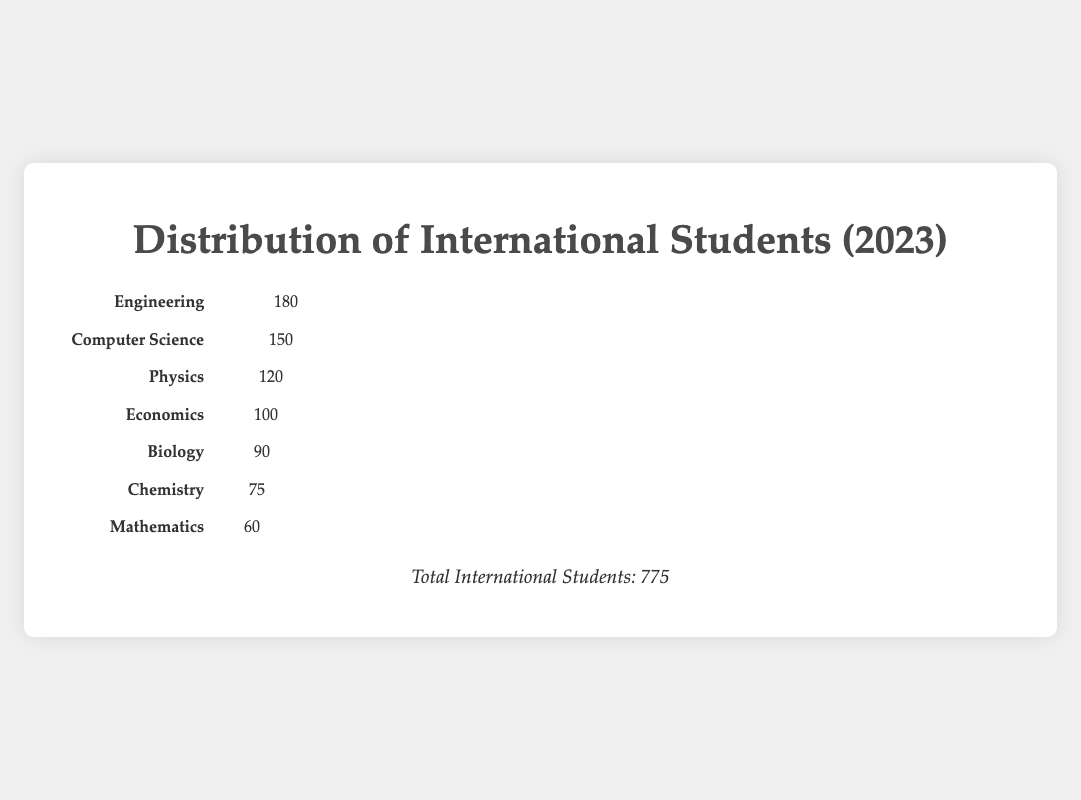Which department has the highest number of international students? The icons and numbers indicate that the Engineering department has the highest number of international students with 180.
Answer: Engineering What is the total number of international students in the Chemistry and Mathematics departments combined? The Chemistry department has 75 international students, and the Mathematics department has 60. Adding these together gives 75 + 60 = 135.
Answer: 135 Which department has more international students, Biology or Computer Science? The Biology department has 90 international students, and the Computer Science department has 150. Since 150 > 90, the Computer Science department has more international students.
Answer: Computer Science How many more international students are there in the Physics department compared to the Mathematics department? The Physics department has 120 international students, and the Mathematics department has 60. The difference is 120 - 60 = 60.
Answer: 60 What percentage of the total international students are enrolled in the Economics department? The Economics department has 100 international students. The total number of international students is 775. The percentage is (100 / 775) * 100 = 12.9%.
Answer: 12.9% Which departments have fewer than 100 international students? The departments with fewer than 100 international students are Biology, Chemistry, and Mathematics, with 90, 75, and 60 students respectively.
Answer: Biology, Chemistry, Mathematics What is the difference in the number of international students between the department with the most and the department with the least students? The Engineering department has the most international students with 180, and the Mathematics department has the least with 60. The difference is 180 - 60 = 120.
Answer: 120 Add the number of international students in the Physics and Computer Science departments. What is the total? The Physics department has 120 international students and the Computer Science department has 150. The total is 120 + 150 = 270.
Answer: 270 Which department has the second highest number of international students? The icons and counts show that the department with the second highest number of international students is Computer Science with 150 students, second only to Engineering with 180.
Answer: Computer Science 